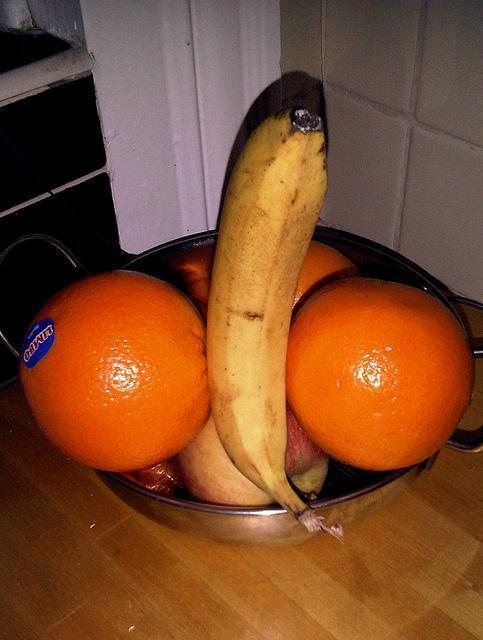How many oranges are seen?
Give a very brief answer. 3. How many oranges are in the photo?
Give a very brief answer. 3. How many apples can be seen?
Give a very brief answer. 2. How many dining tables are there?
Give a very brief answer. 1. 